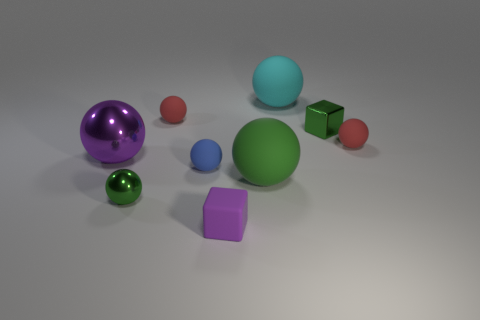There is a large object that is the same color as the small metallic ball; what material is it? It is not possible to determine the exact material solely by the color, as different materials can be painted or treated to achieve the same hue. However, in the context of the image provided, the larger object that matches the color of the small metallic ball appears to be a sphere. That said, if we are assuming that objects of the same color are made of the same material, then the larger sphere would also be made of metal. However, this is purely speculative, as visual evidence is insufficient to determine the material composition. A real-world assessment would require more information, such as texture analysis, weight, response to magnetic forces, or other physical tests. 